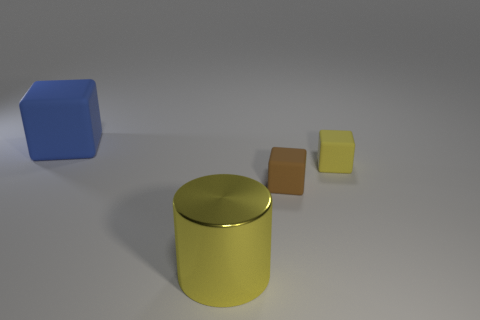Subtract all gray cylinders. Subtract all blue spheres. How many cylinders are left? 1 Subtract all blue cubes. How many brown cylinders are left? 0 Add 2 large yellows. How many browns exist? 0 Subtract all blue metal cylinders. Subtract all matte things. How many objects are left? 1 Add 4 small brown matte blocks. How many small brown matte blocks are left? 5 Add 1 big green cylinders. How many big green cylinders exist? 1 Add 3 yellow rubber objects. How many objects exist? 7 Subtract all brown cubes. How many cubes are left? 2 Subtract all big cubes. How many cubes are left? 2 Subtract 0 cyan blocks. How many objects are left? 4 